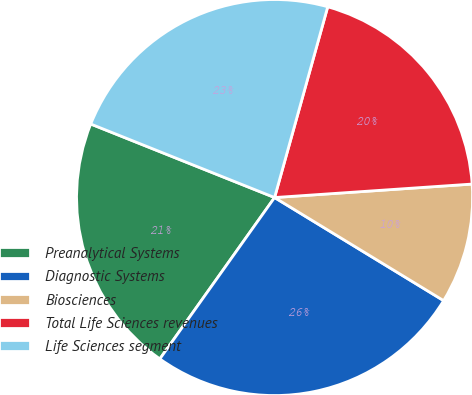Convert chart to OTSL. <chart><loc_0><loc_0><loc_500><loc_500><pie_chart><fcel>Preanalytical Systems<fcel>Diagnostic Systems<fcel>Biosciences<fcel>Total Life Sciences revenues<fcel>Life Sciences segment<nl><fcel>21.22%<fcel>26.12%<fcel>9.8%<fcel>19.59%<fcel>23.27%<nl></chart> 